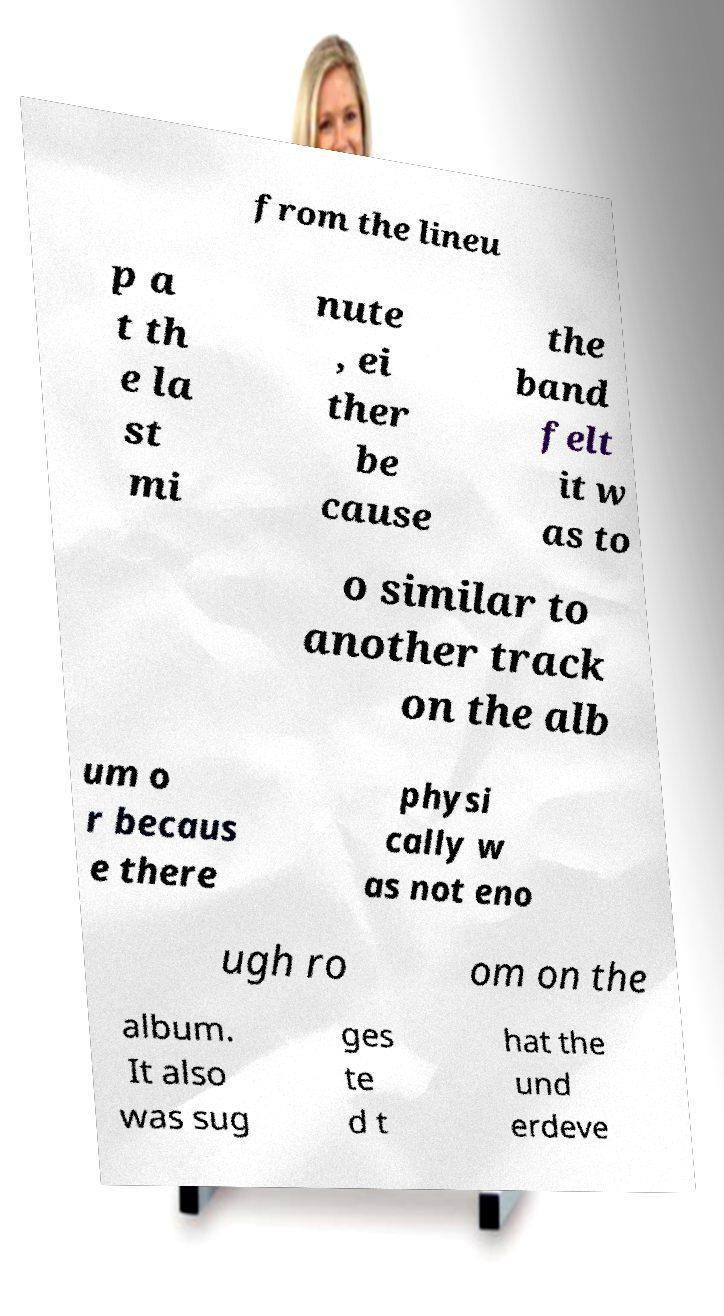Please read and relay the text visible in this image. What does it say? from the lineu p a t th e la st mi nute , ei ther be cause the band felt it w as to o similar to another track on the alb um o r becaus e there physi cally w as not eno ugh ro om on the album. It also was sug ges te d t hat the und erdeve 